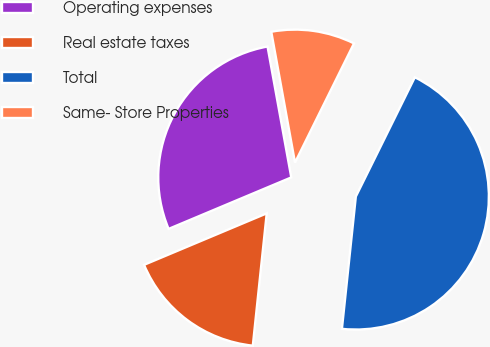Convert chart. <chart><loc_0><loc_0><loc_500><loc_500><pie_chart><fcel>Operating expenses<fcel>Real estate taxes<fcel>Total<fcel>Same- Store Properties<nl><fcel>28.47%<fcel>17.01%<fcel>44.36%<fcel>10.17%<nl></chart> 